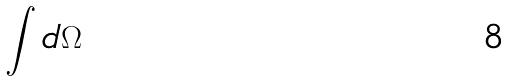<formula> <loc_0><loc_0><loc_500><loc_500>\int d \Omega</formula> 